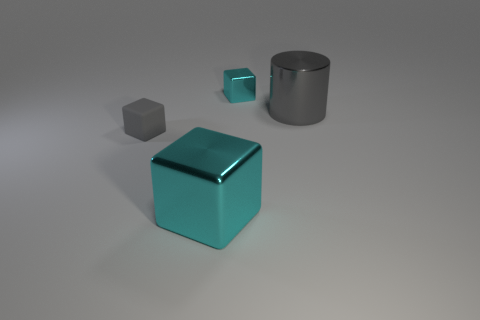There is a cyan thing that is the same size as the metal cylinder; what material is it?
Give a very brief answer. Metal. How many things are either tiny blocks that are in front of the large gray shiny cylinder or cyan shiny objects?
Provide a succinct answer. 3. Is there a large cyan rubber block?
Your response must be concise. No. What is the material of the large object behind the big cyan block?
Your response must be concise. Metal. There is a large cylinder that is the same color as the matte thing; what is its material?
Make the answer very short. Metal. How many large things are either cylinders or green cubes?
Your response must be concise. 1. The tiny metal object has what color?
Provide a succinct answer. Cyan. Are there any big gray metal things behind the cylinder on the right side of the small gray cube?
Your answer should be very brief. No. Is the number of small gray cubes that are right of the rubber object less than the number of large gray things?
Give a very brief answer. Yes. Are the big thing in front of the gray block and the large gray object made of the same material?
Provide a short and direct response. Yes. 